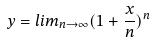<formula> <loc_0><loc_0><loc_500><loc_500>y = l i m _ { n \rightarrow \infty } ( 1 + \frac { x } { n } ) ^ { n }</formula> 